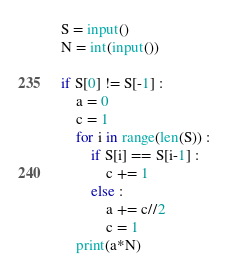Convert code to text. <code><loc_0><loc_0><loc_500><loc_500><_Python_>S = input()
N = int(input())

if S[0] != S[-1] :
    a = 0
    c = 1
    for i in range(len(S)) :
        if S[i] == S[i-1] :
            c += 1
        else :
            a += c//2
            c = 1
    print(a*N)
</code> 